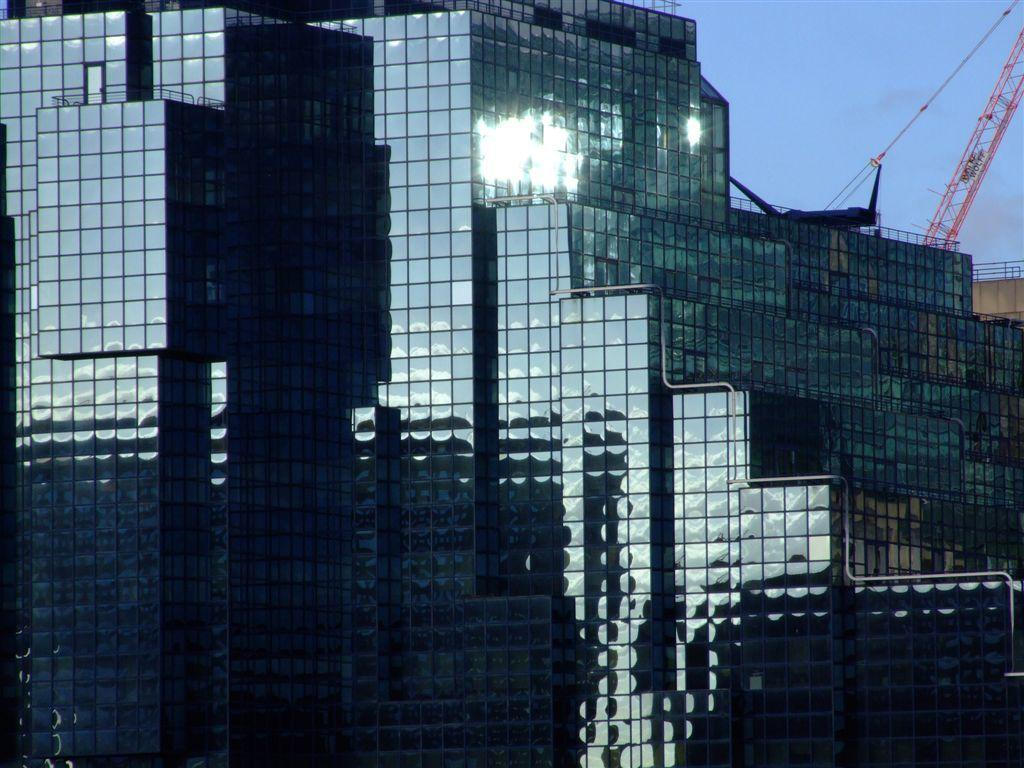What type of building is shown in the image? The image shows the outside view of a glass building. What can be seen in the background of the image? The sky is visible in the image. What type of agreement was reached during the recess on the ship in the image? There is no ship or recess present in the image; it shows the outside view of a glass building with the sky in the background. 